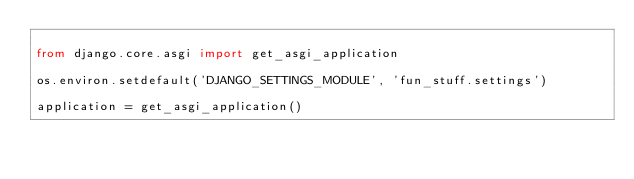Convert code to text. <code><loc_0><loc_0><loc_500><loc_500><_Python_>
from django.core.asgi import get_asgi_application

os.environ.setdefault('DJANGO_SETTINGS_MODULE', 'fun_stuff.settings')

application = get_asgi_application()
</code> 